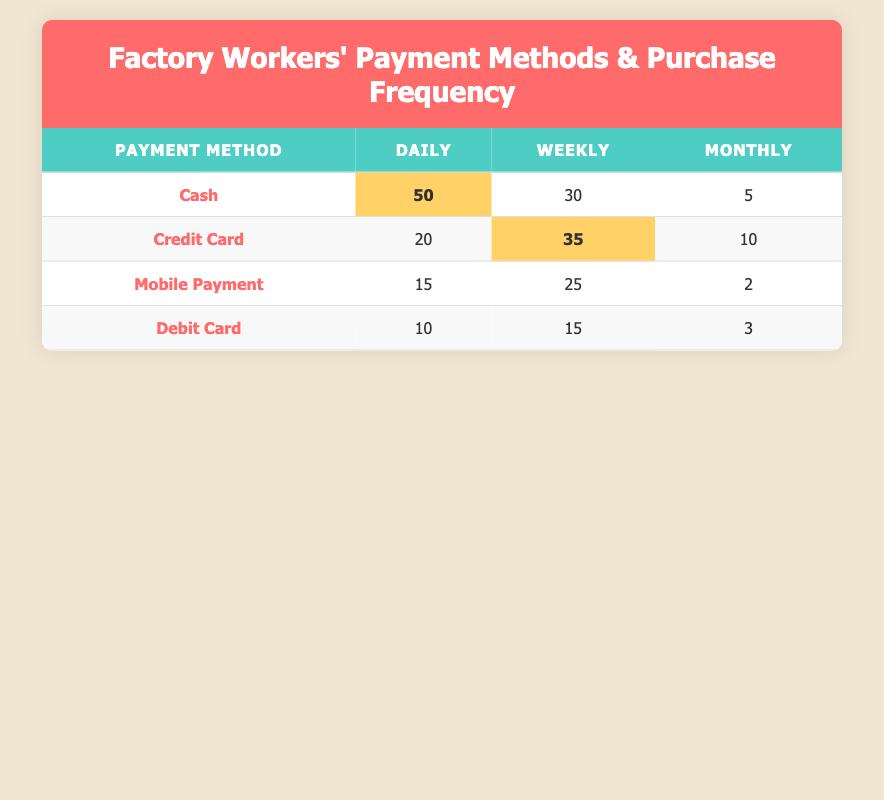What is the most common payment method used by factory workers for daily purchases? The table shows that "Cash" has the highest count of 50 for daily purchases, making it the most common payment method.
Answer: Cash How many factory workers use Mobile Payment weekly? Referring to the Mobile Payment row under the Weekly column, the count is 25 workers.
Answer: 25 Does the number of factory workers using Credit Card for weekly purchases exceed those using Debit Card monthly? The count for Credit Card weekly is 35, while Debit Card monthly is 3. Since 35 is greater than 3, the statement is true.
Answer: Yes What is the total number of purchases made via Debit Card across all frequencies? To find the total, sum the counts for Debit Card: 10 (Daily) + 15 (Weekly) + 3 (Monthly) = 28.
Answer: 28 Which payment method has the lowest monthly usage among factory workers? Looking at the Monthly column, the lowest count is 2 for Mobile Payment.
Answer: Mobile Payment How many more purchases are made with Cash daily compared to Credit Card daily? Cash daily has 50 purchases and Credit Card daily has 20. The difference is 50 - 20 = 30.
Answer: 30 Is it true that more workers use credit cards than mobile payments for weekly purchases? Credit Card weekly has a count of 35 and Mobile Payment weekly has a count of 25. Since 35 is greater than 25, the statement is true.
Answer: Yes What is the average number of purchases per payment method across all frequency categories? To find the average, first total all counts: 50 + 30 + 20 + 35 + 15 + 25 + 10 + 15 + 5 + 10 + 2 + 3 =  260. There are 4 payment methods, so the average is 260 / 4 = 65.
Answer: 65 How many factory workers prefer Cash or Mobile Payment monthly combined? Monthly Cash has 5, and Mobile Payment has 2. The total is 5 + 2 = 7 workers.
Answer: 7 